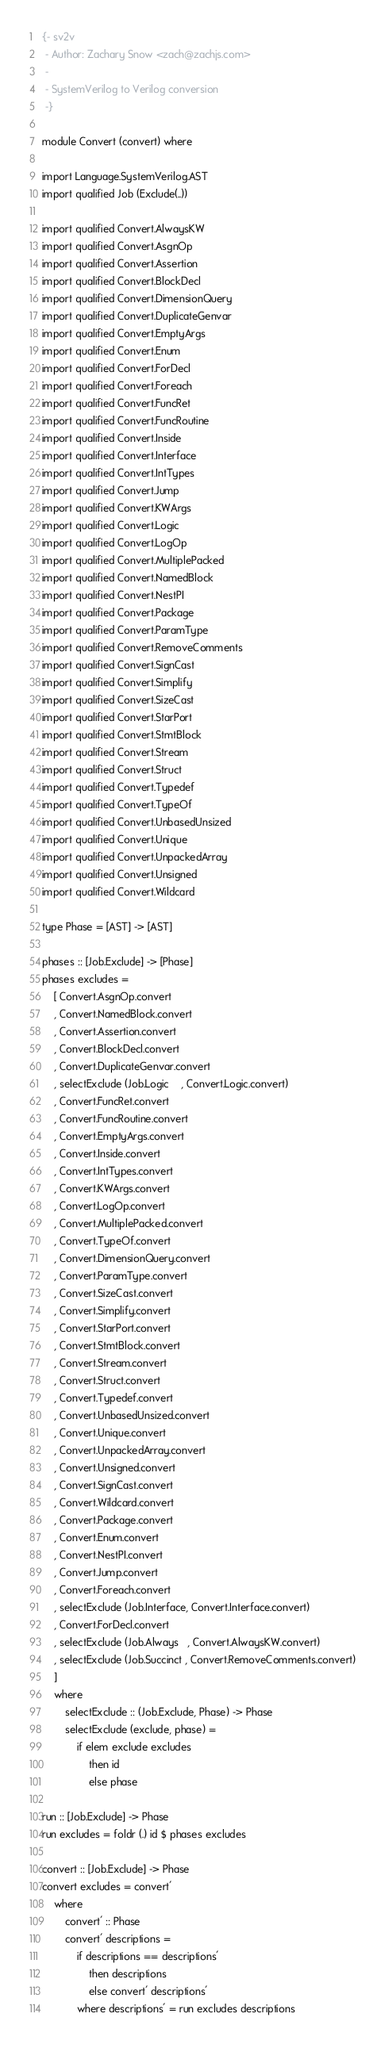<code> <loc_0><loc_0><loc_500><loc_500><_Haskell_>{- sv2v
 - Author: Zachary Snow <zach@zachjs.com>
 -
 - SystemVerilog to Verilog conversion
 -}

module Convert (convert) where

import Language.SystemVerilog.AST
import qualified Job (Exclude(..))

import qualified Convert.AlwaysKW
import qualified Convert.AsgnOp
import qualified Convert.Assertion
import qualified Convert.BlockDecl
import qualified Convert.DimensionQuery
import qualified Convert.DuplicateGenvar
import qualified Convert.EmptyArgs
import qualified Convert.Enum
import qualified Convert.ForDecl
import qualified Convert.Foreach
import qualified Convert.FuncRet
import qualified Convert.FuncRoutine
import qualified Convert.Inside
import qualified Convert.Interface
import qualified Convert.IntTypes
import qualified Convert.Jump
import qualified Convert.KWArgs
import qualified Convert.Logic
import qualified Convert.LogOp
import qualified Convert.MultiplePacked
import qualified Convert.NamedBlock
import qualified Convert.NestPI
import qualified Convert.Package
import qualified Convert.ParamType
import qualified Convert.RemoveComments
import qualified Convert.SignCast
import qualified Convert.Simplify
import qualified Convert.SizeCast
import qualified Convert.StarPort
import qualified Convert.StmtBlock
import qualified Convert.Stream
import qualified Convert.Struct
import qualified Convert.Typedef
import qualified Convert.TypeOf
import qualified Convert.UnbasedUnsized
import qualified Convert.Unique
import qualified Convert.UnpackedArray
import qualified Convert.Unsigned
import qualified Convert.Wildcard

type Phase = [AST] -> [AST]

phases :: [Job.Exclude] -> [Phase]
phases excludes =
    [ Convert.AsgnOp.convert
    , Convert.NamedBlock.convert
    , Convert.Assertion.convert
    , Convert.BlockDecl.convert
    , Convert.DuplicateGenvar.convert
    , selectExclude (Job.Logic    , Convert.Logic.convert)
    , Convert.FuncRet.convert
    , Convert.FuncRoutine.convert
    , Convert.EmptyArgs.convert
    , Convert.Inside.convert
    , Convert.IntTypes.convert
    , Convert.KWArgs.convert
    , Convert.LogOp.convert
    , Convert.MultiplePacked.convert
    , Convert.TypeOf.convert
    , Convert.DimensionQuery.convert
    , Convert.ParamType.convert
    , Convert.SizeCast.convert
    , Convert.Simplify.convert
    , Convert.StarPort.convert
    , Convert.StmtBlock.convert
    , Convert.Stream.convert
    , Convert.Struct.convert
    , Convert.Typedef.convert
    , Convert.UnbasedUnsized.convert
    , Convert.Unique.convert
    , Convert.UnpackedArray.convert
    , Convert.Unsigned.convert
    , Convert.SignCast.convert
    , Convert.Wildcard.convert
    , Convert.Package.convert
    , Convert.Enum.convert
    , Convert.NestPI.convert
    , Convert.Jump.convert
    , Convert.Foreach.convert
    , selectExclude (Job.Interface, Convert.Interface.convert)
    , Convert.ForDecl.convert
    , selectExclude (Job.Always   , Convert.AlwaysKW.convert)
    , selectExclude (Job.Succinct , Convert.RemoveComments.convert)
    ]
    where
        selectExclude :: (Job.Exclude, Phase) -> Phase
        selectExclude (exclude, phase) =
            if elem exclude excludes
                then id
                else phase

run :: [Job.Exclude] -> Phase
run excludes = foldr (.) id $ phases excludes

convert :: [Job.Exclude] -> Phase
convert excludes = convert'
    where
        convert' :: Phase
        convert' descriptions =
            if descriptions == descriptions'
                then descriptions
                else convert' descriptions'
            where descriptions' = run excludes descriptions
</code> 